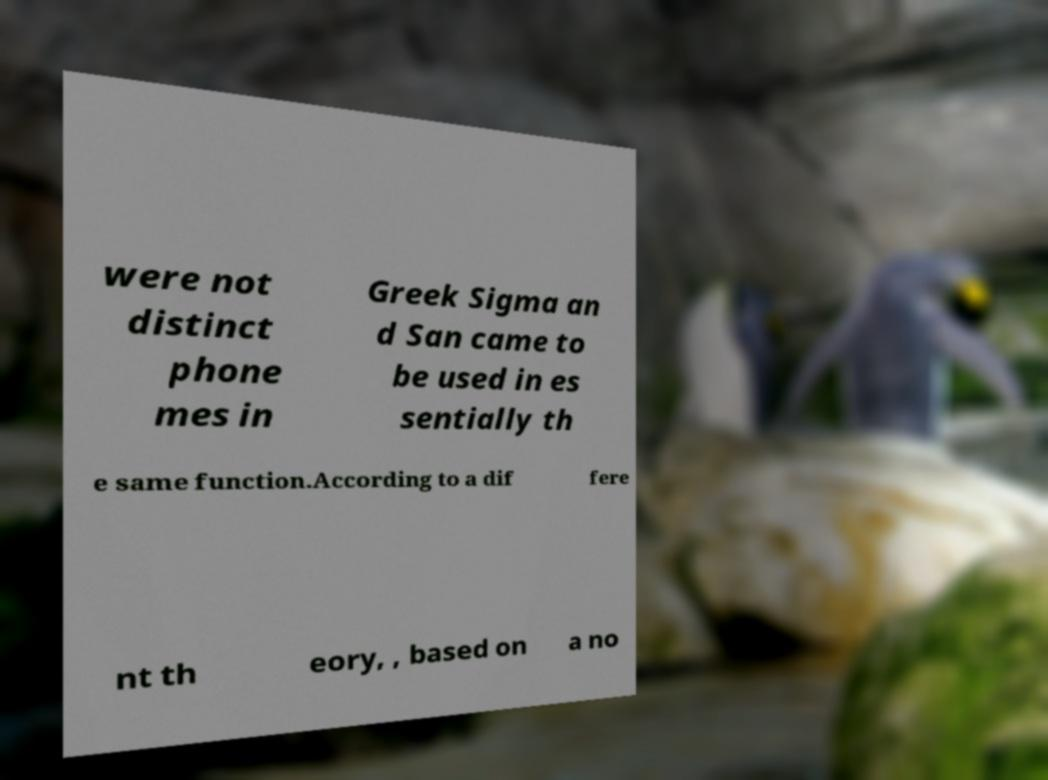What messages or text are displayed in this image? I need them in a readable, typed format. were not distinct phone mes in Greek Sigma an d San came to be used in es sentially th e same function.According to a dif fere nt th eory, , based on a no 